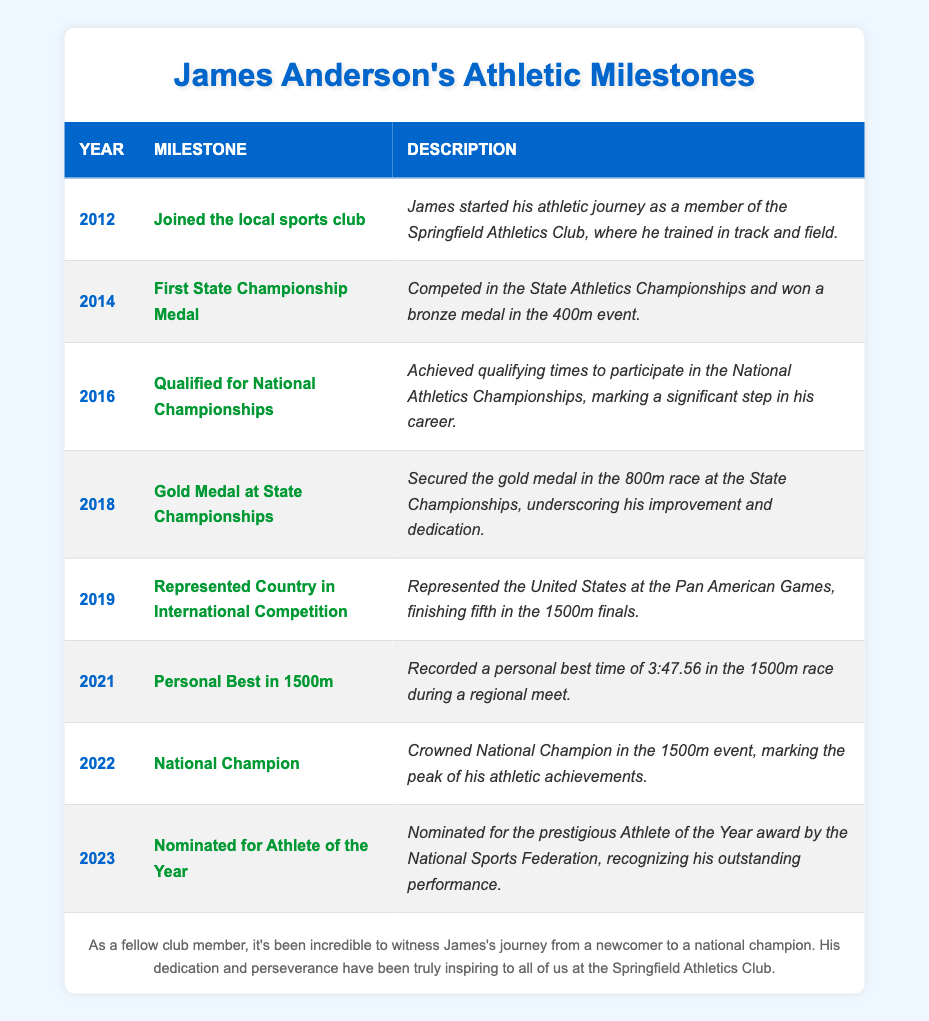What year did James Anderson join the local sports club? In the table, the first milestone listed shows that James joined the local sports club in 2012.
Answer: 2012 How many years was it from when James first won a state championship medal to when he became a national champion? James won his first state championship medal in 2014 and became a national champion in 2022. The difference between these years is 2022 - 2014 = 8 years.
Answer: 8 years Did James ever win a medal in the 1500m event? The table states that in 2019, he finished fifth in the 1500m finals at the Pan American Games, but it does not indicate that he won a medal at that event. Thus, he did not win a medal in the 1500m event.
Answer: No What was the milestone achieved immediately before being nominated for Athlete of the Year? The nomination for Athlete of the Year in 2023 followed the milestone of being crowned National Champion in 2022. Thus, National Champion was the milestone achieved immediately before the nomination.
Answer: National Champion How many significant milestones did James achieve between 2012 and 2022? By counting the milestones listed in the table from 2012 to 2022, there are seven milestones (2012, 2014, 2016, 2018, 2019, 2021, and 2022).
Answer: 7 In what year did James achieve his personal best in the 1500m? The table indicates that James recorded his personal best in the 1500m in 2021.
Answer: 2021 What is the difference in years between when James represented the country in international competition and when he won his first state championship medal? James represented the country in 2019 and won his first state championship medal in 2014. The difference is 2019 - 2014 = 5 years.
Answer: 5 years How many milestones indicate medals or championships won by James? In the table, milestones indicating medals or championships are: the first state championship medal (2014), gold medal at state championships (2018), and national champion (2022). Thus, there are three such milestones.
Answer: 3 What was the milestone achieved by James in 2018? The table states that in 2018, James secured the gold medal in the 800m race at the State Championships.
Answer: Gold Medal at State Championships Which milestone marks James's peak athletic achievement? According to the table, being crowned National Champion in 2022 marks the peak of James's athletic achievements.
Answer: National Champion 